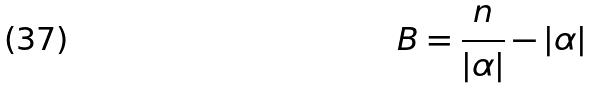Convert formula to latex. <formula><loc_0><loc_0><loc_500><loc_500>B = \frac { n } { | \alpha | } - | \alpha |</formula> 